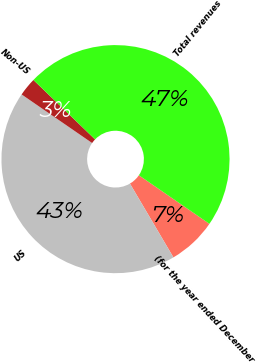<chart> <loc_0><loc_0><loc_500><loc_500><pie_chart><fcel>(for the year ended December<fcel>US<fcel>Non-US<fcel>Total revenues<nl><fcel>6.92%<fcel>43.08%<fcel>2.61%<fcel>47.39%<nl></chart> 